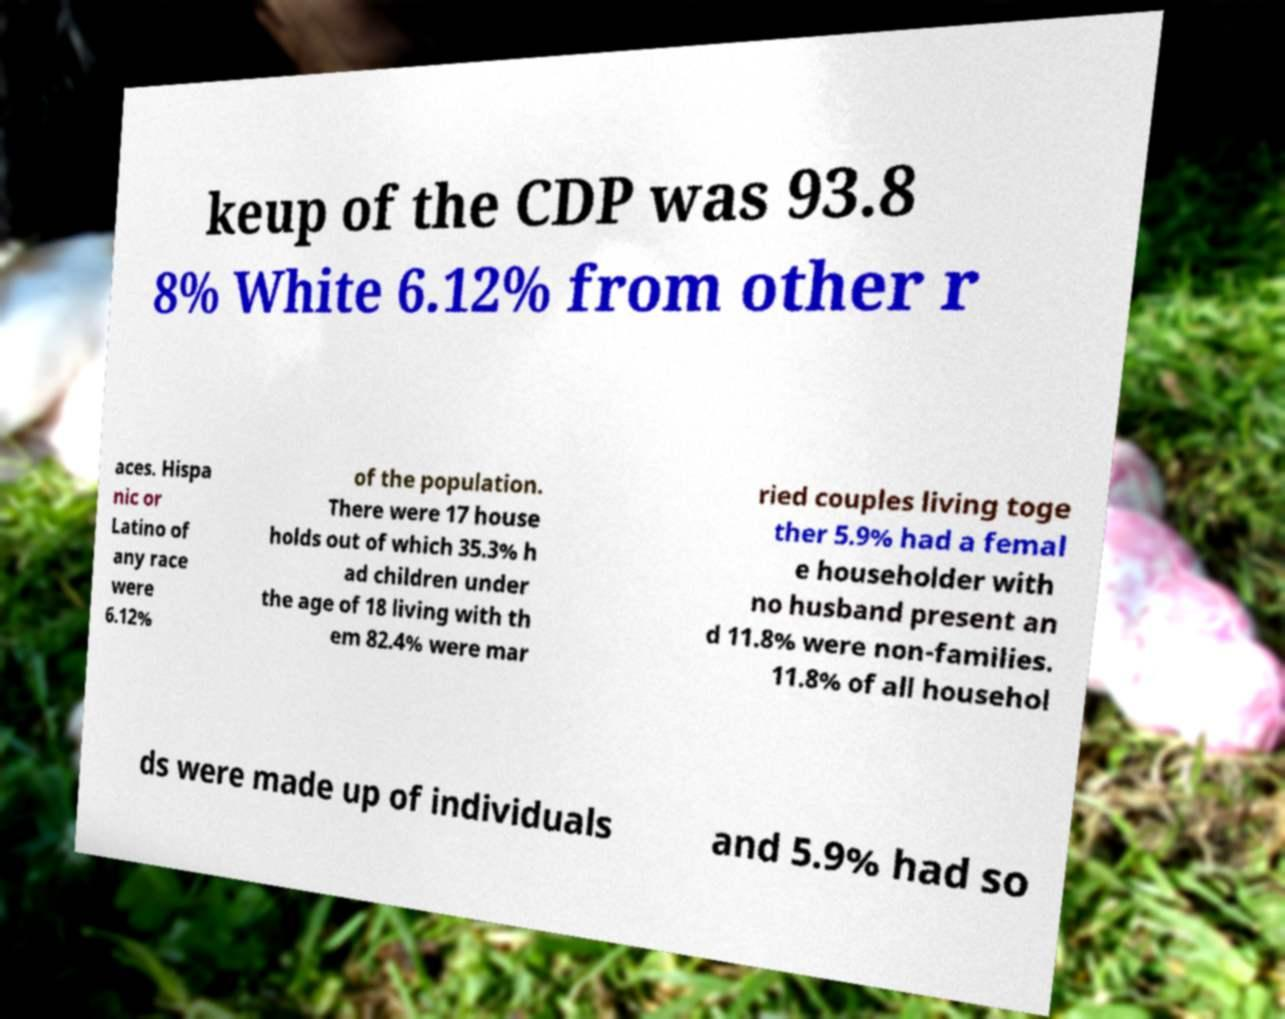Could you assist in decoding the text presented in this image and type it out clearly? keup of the CDP was 93.8 8% White 6.12% from other r aces. Hispa nic or Latino of any race were 6.12% of the population. There were 17 house holds out of which 35.3% h ad children under the age of 18 living with th em 82.4% were mar ried couples living toge ther 5.9% had a femal e householder with no husband present an d 11.8% were non-families. 11.8% of all househol ds were made up of individuals and 5.9% had so 